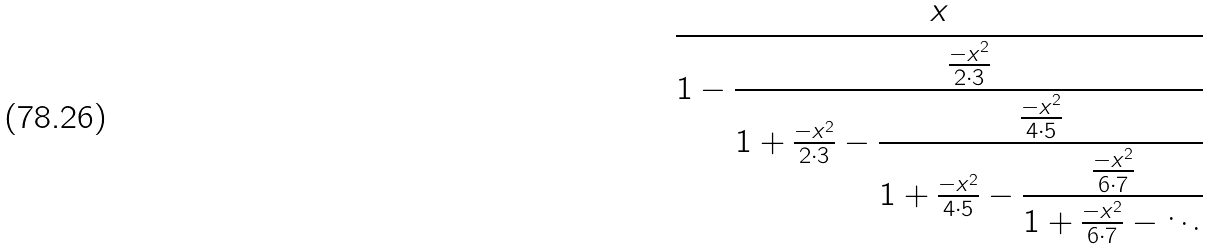<formula> <loc_0><loc_0><loc_500><loc_500>\cfrac { x } { 1 - { \cfrac { \frac { - x ^ { 2 } } { 2 \cdot 3 } } { 1 + { \frac { - x ^ { 2 } } { 2 \cdot 3 } } - { \cfrac { \frac { - x ^ { 2 } } { 4 \cdot 5 } } { 1 + { \frac { - x ^ { 2 } } { 4 \cdot 5 } } - { \cfrac { \frac { - x ^ { 2 } } { 6 \cdot 7 } } { 1 + { \frac { - x ^ { 2 } } { 6 \cdot 7 } } - \ddots } } } } } } }</formula> 